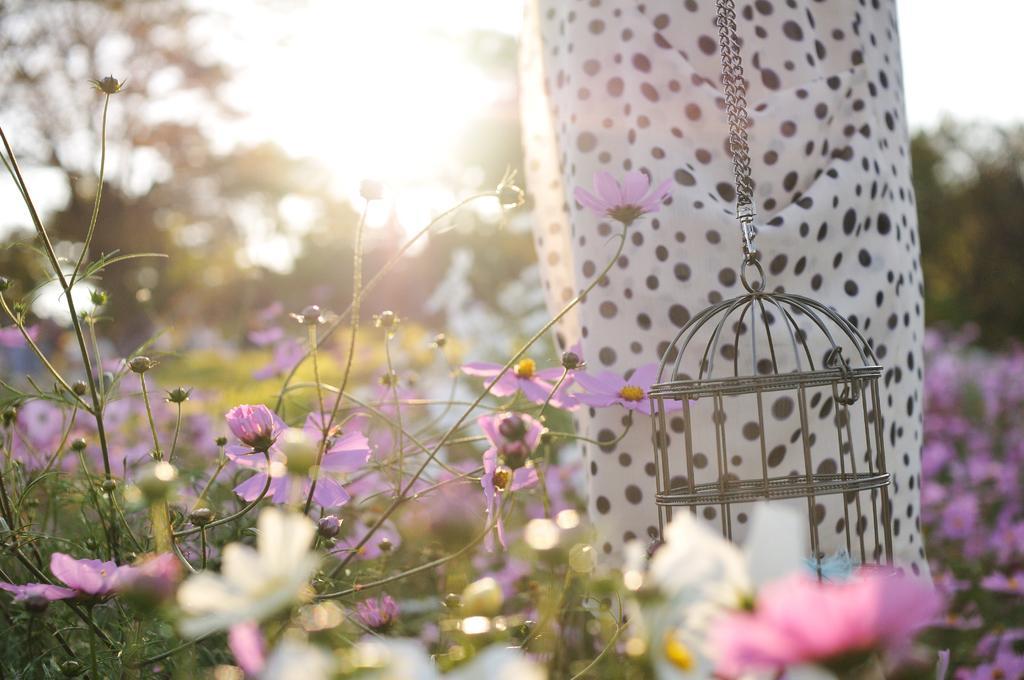Could you give a brief overview of what you see in this image? In this image in front there are plants and flowers. Behind the plants there is a bird cage. Behind the cage there is some object. In the background of the image there are trees. 